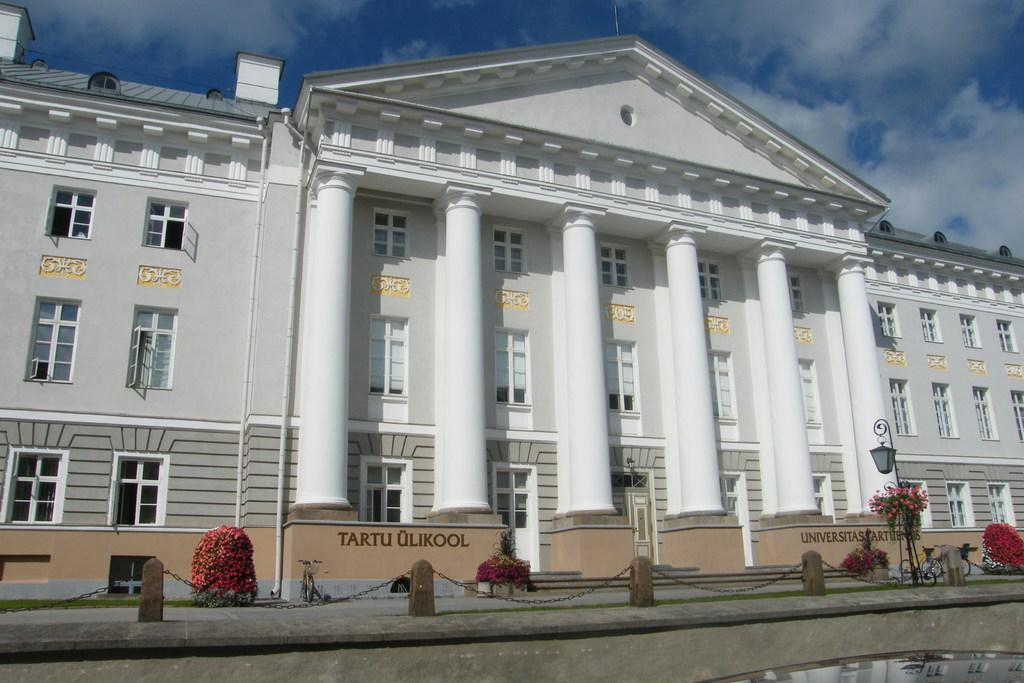What is the main structure in the center of the image? There is a building in the center of the image. What can be seen at the bottom of the image? There are plants, a fence, flower pots, and lights at the bottom of the image. What is visible at the top of the image? The sky is visible at the top of the image. What type of dinner is being served in the image? There is no dinner present in the image; it features a building, plants, a fence, flower pots, lights, and the sky. What process is being carried out in the image? There is no specific process being carried out in the image; it is a static scene featuring a building, plants, a fence, flower pots, lights, and the sky. 